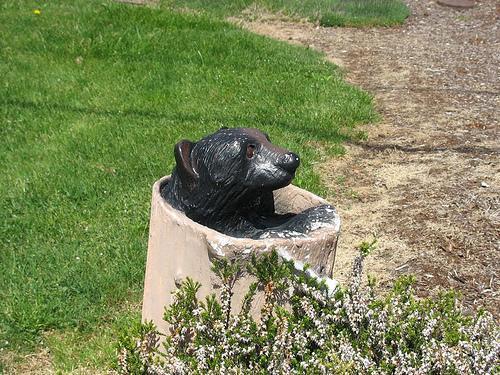How many bears are there?
Give a very brief answer. 1. 